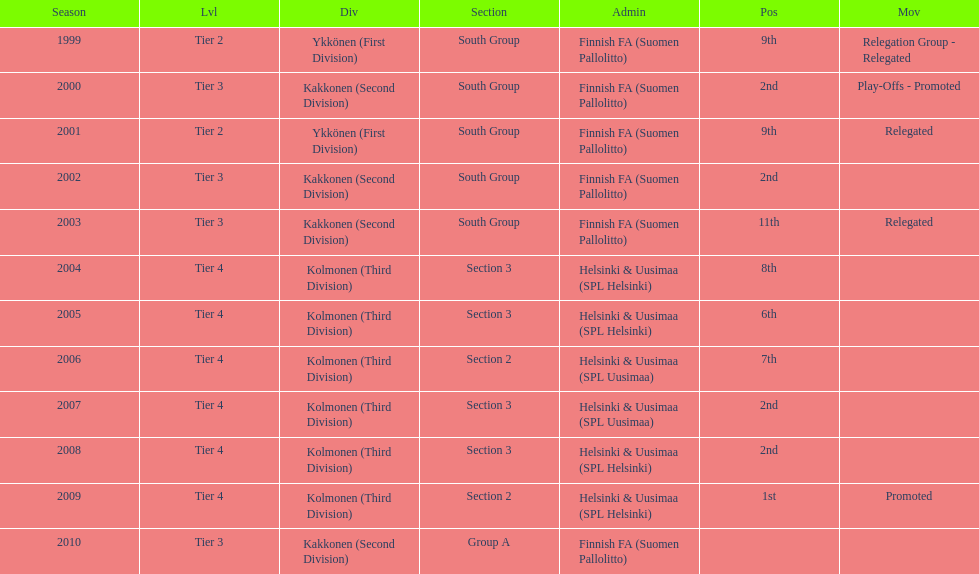Give me the full table as a dictionary. {'header': ['Season', 'Lvl', 'Div', 'Section', 'Admin', 'Pos', 'Mov'], 'rows': [['1999', 'Tier 2', 'Ykkönen (First Division)', 'South Group', 'Finnish FA (Suomen Pallolitto)', '9th', 'Relegation Group - Relegated'], ['2000', 'Tier 3', 'Kakkonen (Second Division)', 'South Group', 'Finnish FA (Suomen Pallolitto)', '2nd', 'Play-Offs - Promoted'], ['2001', 'Tier 2', 'Ykkönen (First Division)', 'South Group', 'Finnish FA (Suomen Pallolitto)', '9th', 'Relegated'], ['2002', 'Tier 3', 'Kakkonen (Second Division)', 'South Group', 'Finnish FA (Suomen Pallolitto)', '2nd', ''], ['2003', 'Tier 3', 'Kakkonen (Second Division)', 'South Group', 'Finnish FA (Suomen Pallolitto)', '11th', 'Relegated'], ['2004', 'Tier 4', 'Kolmonen (Third Division)', 'Section 3', 'Helsinki & Uusimaa (SPL Helsinki)', '8th', ''], ['2005', 'Tier 4', 'Kolmonen (Third Division)', 'Section 3', 'Helsinki & Uusimaa (SPL Helsinki)', '6th', ''], ['2006', 'Tier 4', 'Kolmonen (Third Division)', 'Section 2', 'Helsinki & Uusimaa (SPL Uusimaa)', '7th', ''], ['2007', 'Tier 4', 'Kolmonen (Third Division)', 'Section 3', 'Helsinki & Uusimaa (SPL Uusimaa)', '2nd', ''], ['2008', 'Tier 4', 'Kolmonen (Third Division)', 'Section 3', 'Helsinki & Uusimaa (SPL Helsinki)', '2nd', ''], ['2009', 'Tier 4', 'Kolmonen (Third Division)', 'Section 2', 'Helsinki & Uusimaa (SPL Helsinki)', '1st', 'Promoted'], ['2010', 'Tier 3', 'Kakkonen (Second Division)', 'Group A', 'Finnish FA (Suomen Pallolitto)', '', '']]} How many times were they in tier 3? 4. 